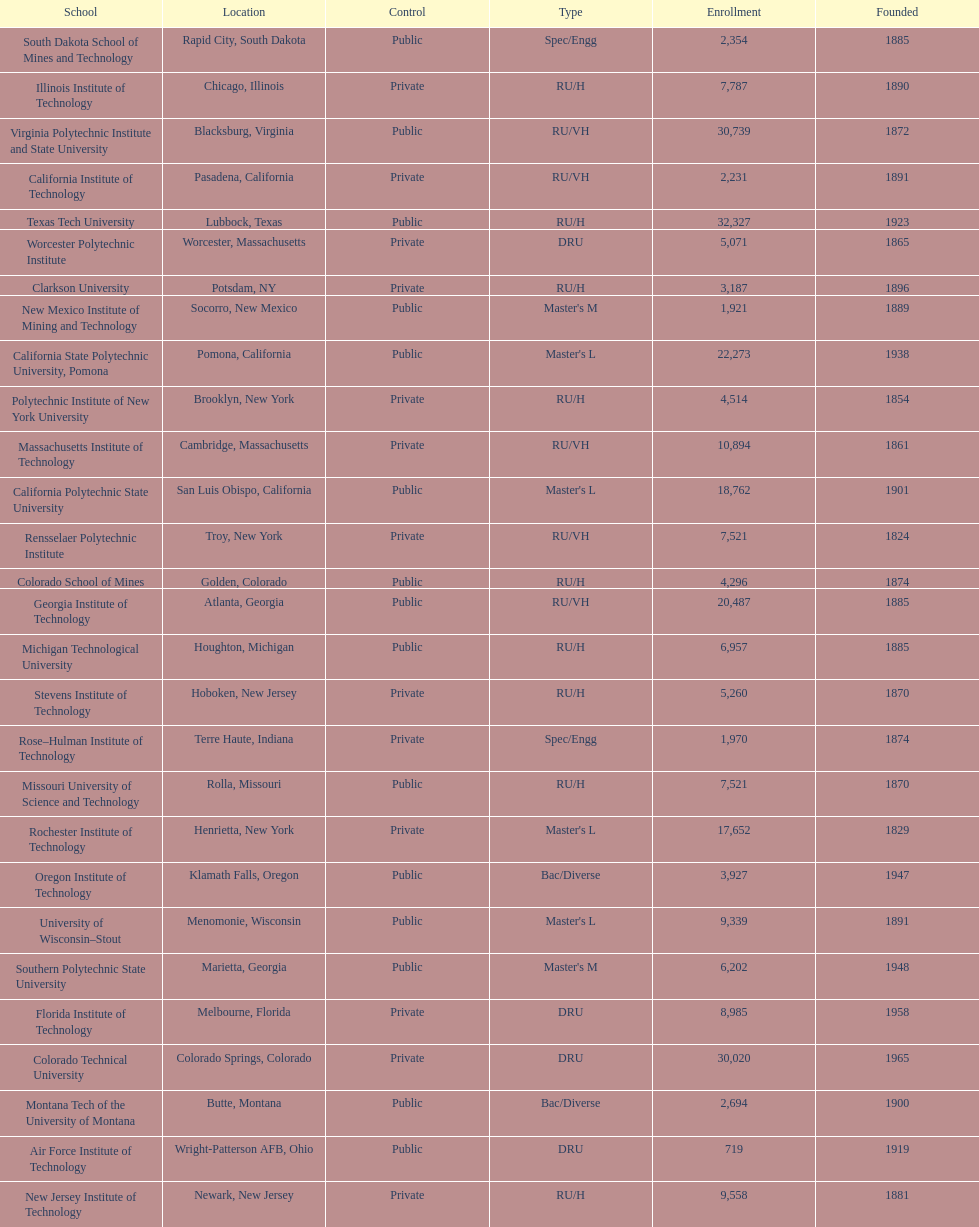Would you be able to parse every entry in this table? {'header': ['School', 'Location', 'Control', 'Type', 'Enrollment', 'Founded'], 'rows': [['South Dakota School of Mines and Technology', 'Rapid City, South Dakota', 'Public', 'Spec/Engg', '2,354', '1885'], ['Illinois Institute of Technology', 'Chicago, Illinois', 'Private', 'RU/H', '7,787', '1890'], ['Virginia Polytechnic Institute and State University', 'Blacksburg, Virginia', 'Public', 'RU/VH', '30,739', '1872'], ['California Institute of Technology', 'Pasadena, California', 'Private', 'RU/VH', '2,231', '1891'], ['Texas Tech University', 'Lubbock, Texas', 'Public', 'RU/H', '32,327', '1923'], ['Worcester Polytechnic Institute', 'Worcester, Massachusetts', 'Private', 'DRU', '5,071', '1865'], ['Clarkson University', 'Potsdam, NY', 'Private', 'RU/H', '3,187', '1896'], ['New Mexico Institute of Mining and Technology', 'Socorro, New Mexico', 'Public', "Master's M", '1,921', '1889'], ['California State Polytechnic University, Pomona', 'Pomona, California', 'Public', "Master's L", '22,273', '1938'], ['Polytechnic Institute of New York University', 'Brooklyn, New York', 'Private', 'RU/H', '4,514', '1854'], ['Massachusetts Institute of Technology', 'Cambridge, Massachusetts', 'Private', 'RU/VH', '10,894', '1861'], ['California Polytechnic State University', 'San Luis Obispo, California', 'Public', "Master's L", '18,762', '1901'], ['Rensselaer Polytechnic Institute', 'Troy, New York', 'Private', 'RU/VH', '7,521', '1824'], ['Colorado School of Mines', 'Golden, Colorado', 'Public', 'RU/H', '4,296', '1874'], ['Georgia Institute of Technology', 'Atlanta, Georgia', 'Public', 'RU/VH', '20,487', '1885'], ['Michigan Technological University', 'Houghton, Michigan', 'Public', 'RU/H', '6,957', '1885'], ['Stevens Institute of Technology', 'Hoboken, New Jersey', 'Private', 'RU/H', '5,260', '1870'], ['Rose–Hulman Institute of Technology', 'Terre Haute, Indiana', 'Private', 'Spec/Engg', '1,970', '1874'], ['Missouri University of Science and Technology', 'Rolla, Missouri', 'Public', 'RU/H', '7,521', '1870'], ['Rochester Institute of Technology', 'Henrietta, New York', 'Private', "Master's L", '17,652', '1829'], ['Oregon Institute of Technology', 'Klamath Falls, Oregon', 'Public', 'Bac/Diverse', '3,927', '1947'], ['University of Wisconsin–Stout', 'Menomonie, Wisconsin', 'Public', "Master's L", '9,339', '1891'], ['Southern Polytechnic State University', 'Marietta, Georgia', 'Public', "Master's M", '6,202', '1948'], ['Florida Institute of Technology', 'Melbourne, Florida', 'Private', 'DRU', '8,985', '1958'], ['Colorado Technical University', 'Colorado Springs, Colorado', 'Private', 'DRU', '30,020', '1965'], ['Montana Tech of the University of Montana', 'Butte, Montana', 'Public', 'Bac/Diverse', '2,694', '1900'], ['Air Force Institute of Technology', 'Wright-Patterson AFB, Ohio', 'Public', 'DRU', '719', '1919'], ['New Jersey Institute of Technology', 'Newark, New Jersey', 'Private', 'RU/H', '9,558', '1881']]} What's the number of schools represented in the table? 28. 